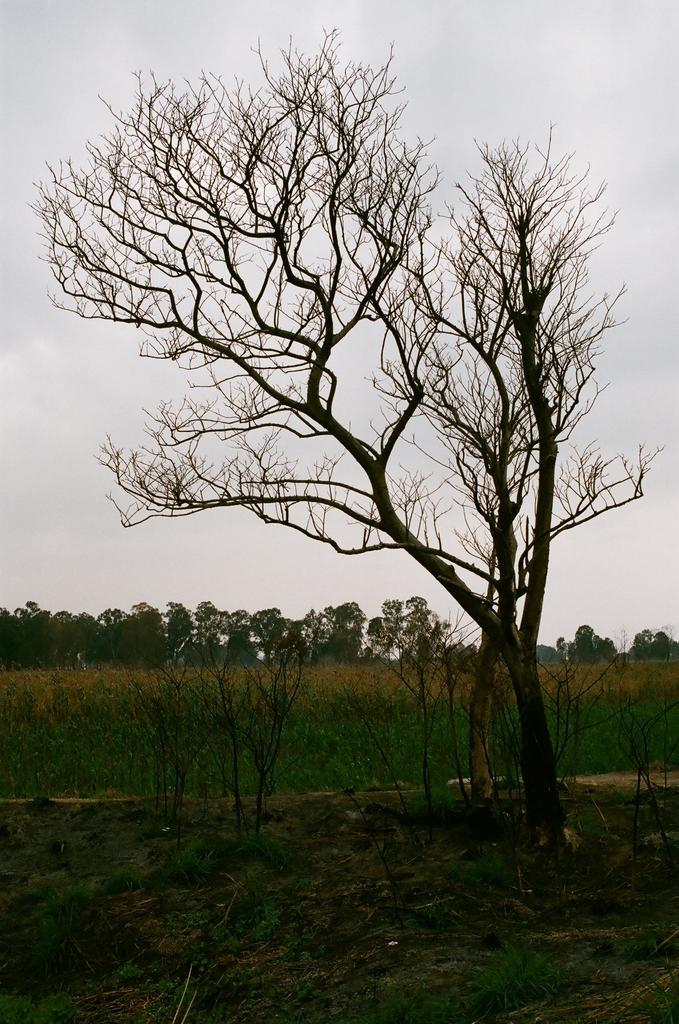What is located in the foreground of the image? There is a tree in the foreground of the image. What is the position of the tree in relation to the ground? The tree is on the ground. What can be seen in the background of the image? There are plants, trees, and the sky visible in the background of the image. What degree does the expert in the image hold? There is no expert present in the image, as it only features a tree in the foreground and plants, trees, and the sky in the background. 